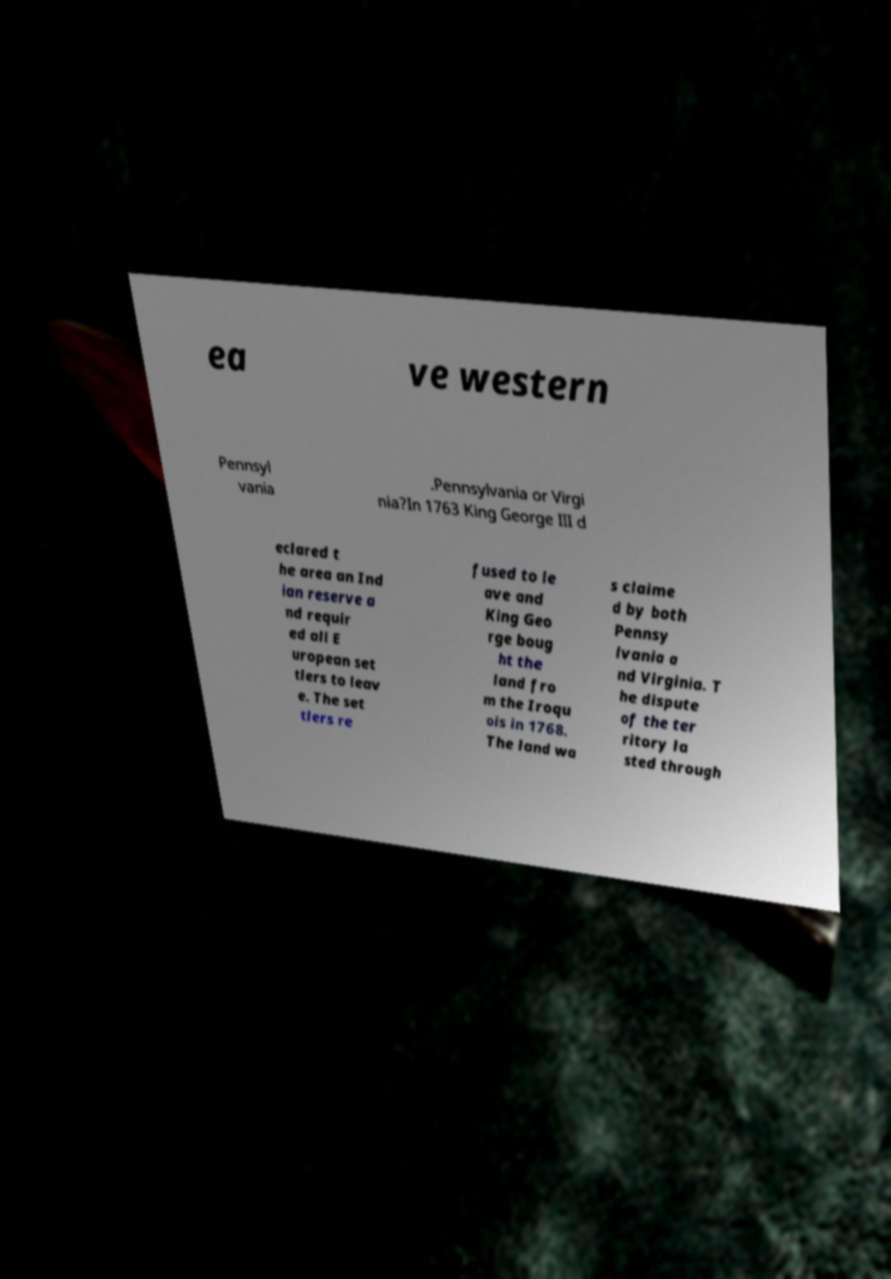Could you extract and type out the text from this image? ea ve western Pennsyl vania .Pennsylvania or Virgi nia?In 1763 King George III d eclared t he area an Ind ian reserve a nd requir ed all E uropean set tlers to leav e. The set tlers re fused to le ave and King Geo rge boug ht the land fro m the Iroqu ois in 1768. The land wa s claime d by both Pennsy lvania a nd Virginia. T he dispute of the ter ritory la sted through 